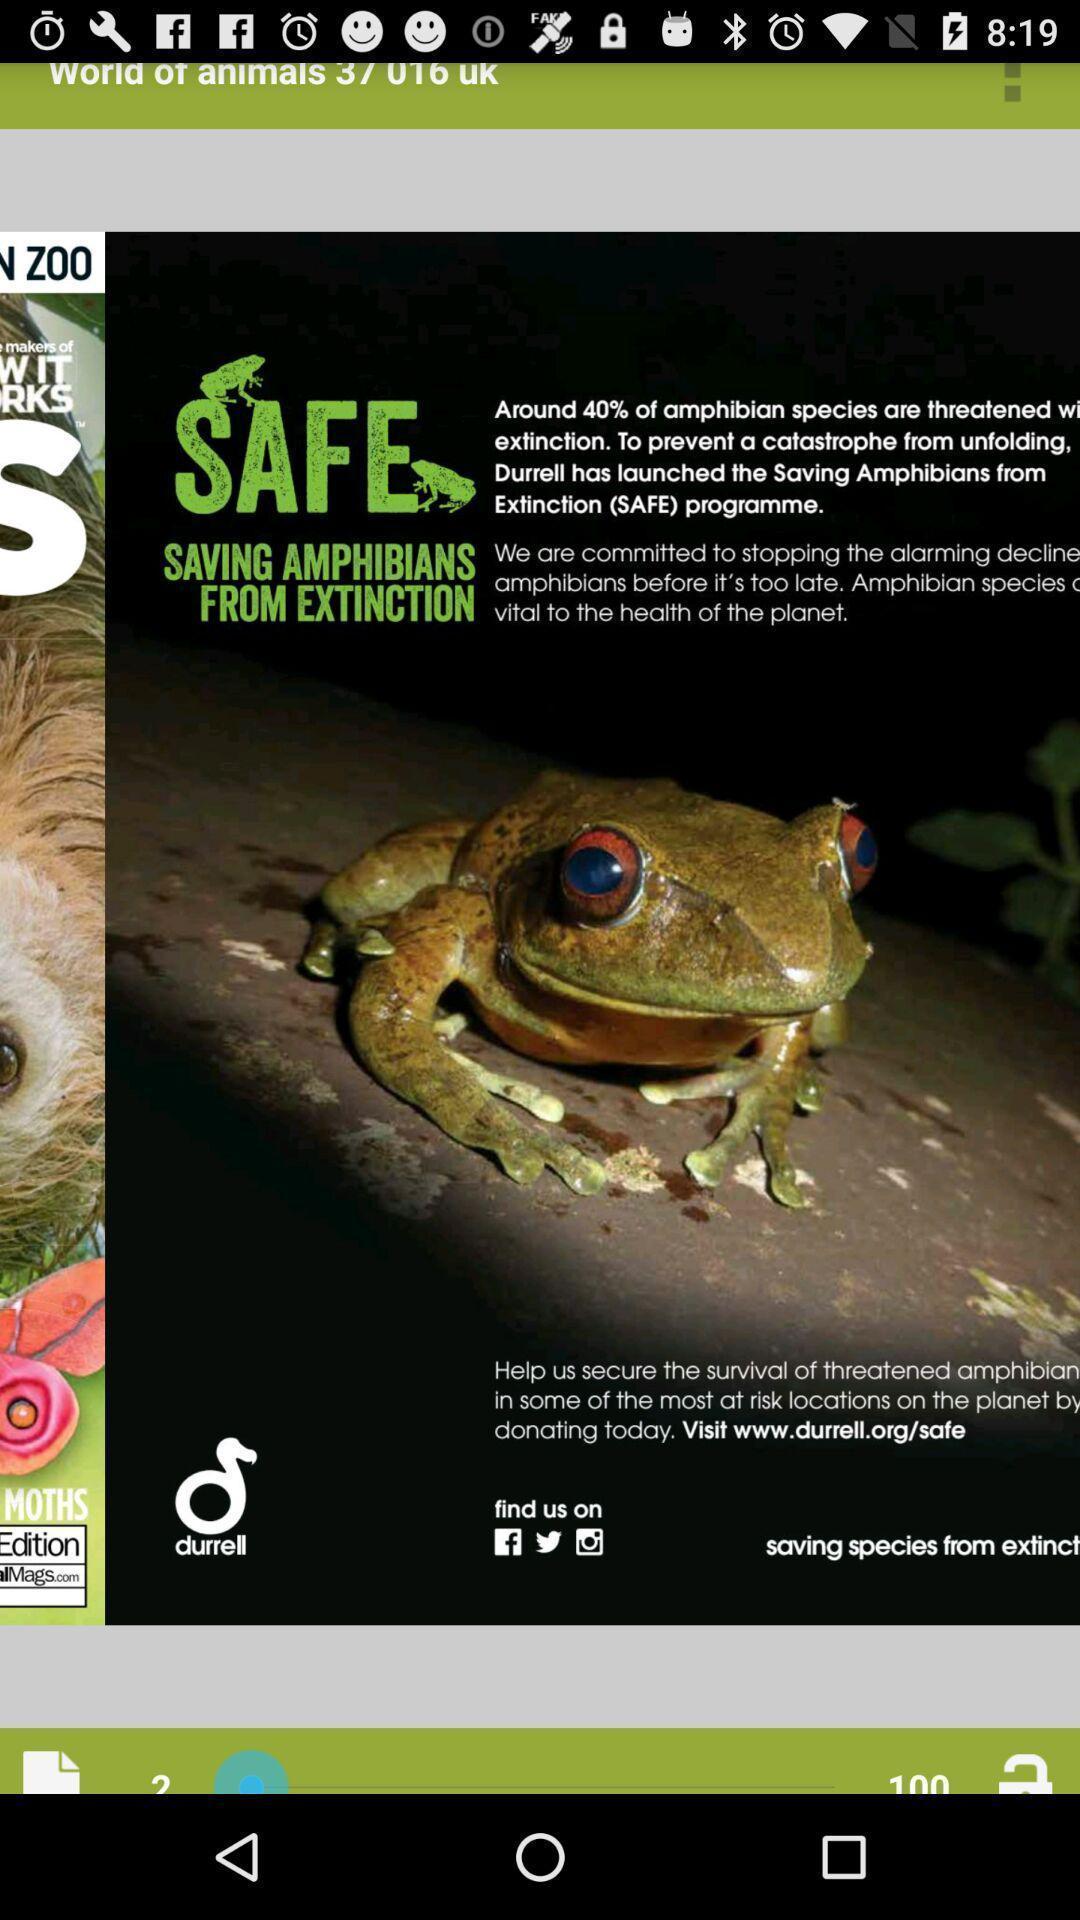Describe the key features of this screenshot. Page giving information about the amphibians. 